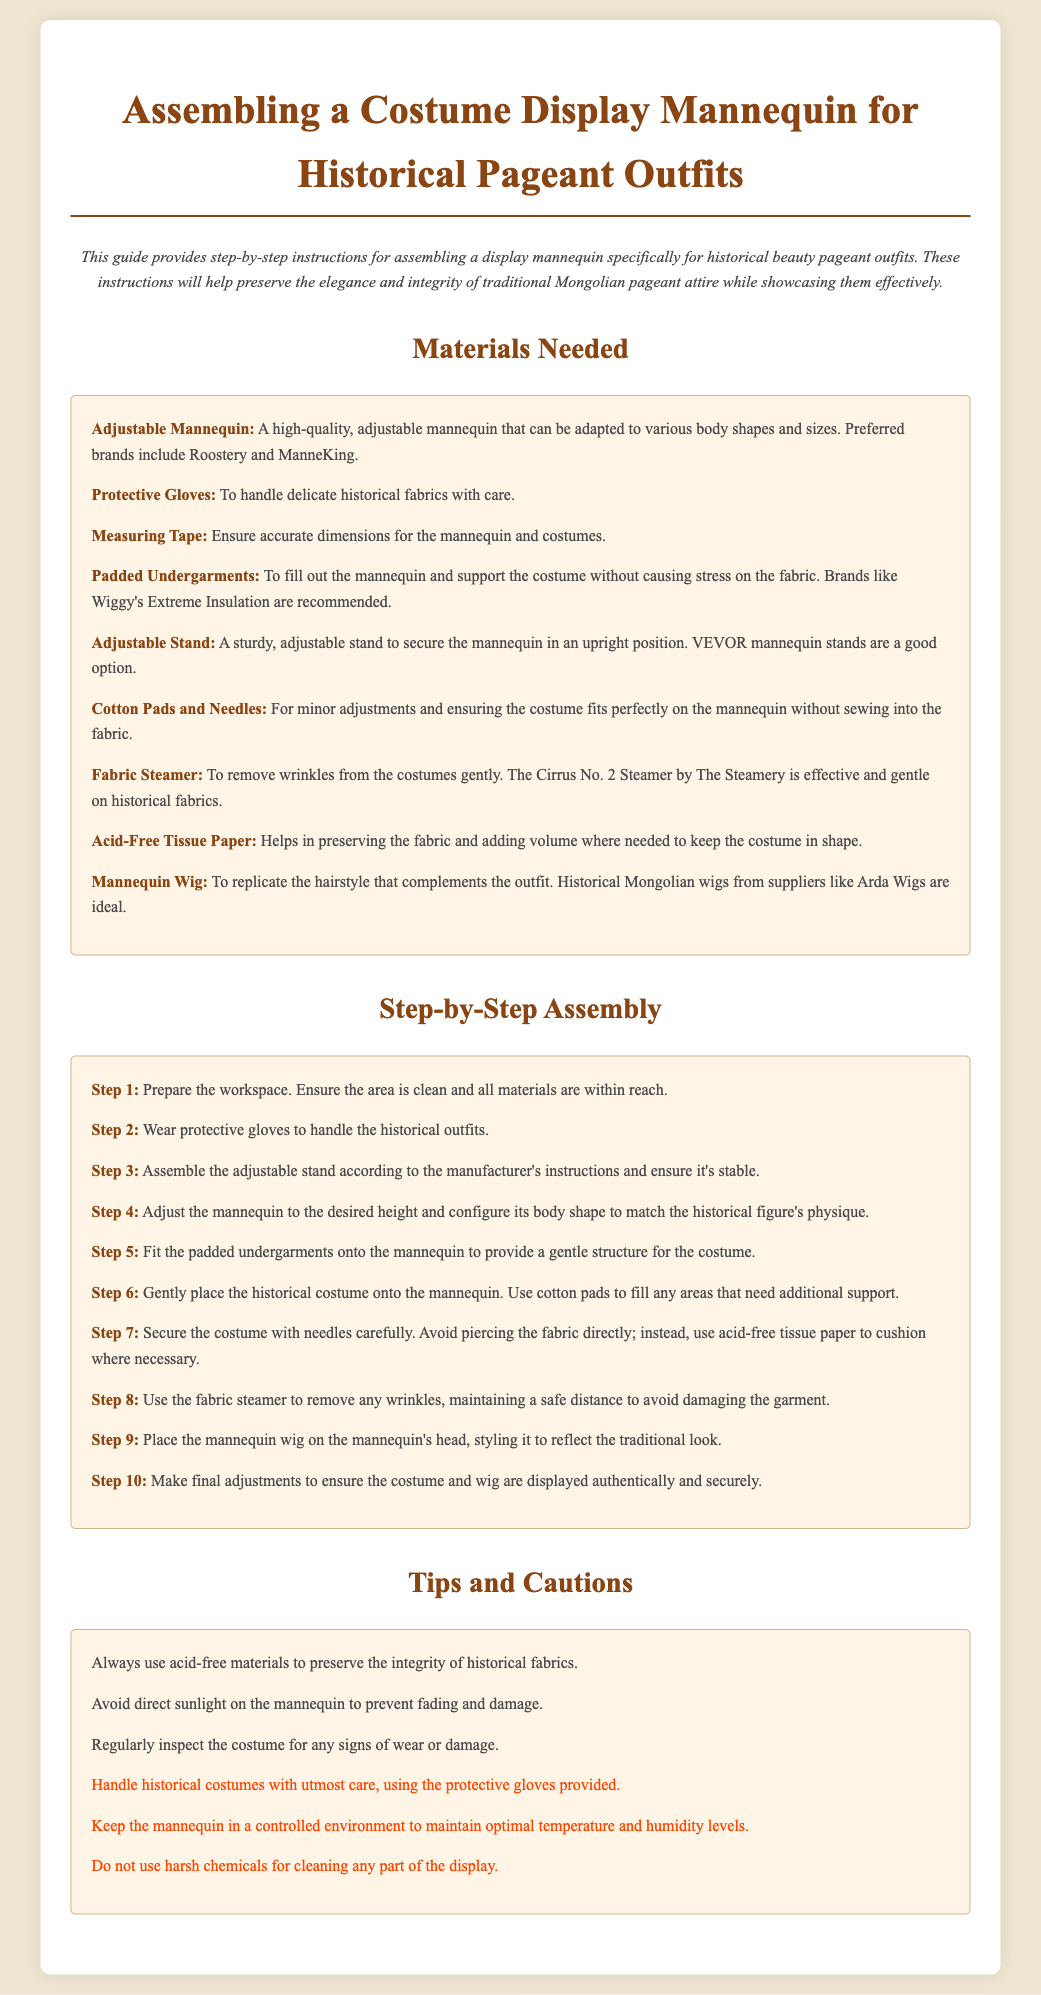What is the title of the document? The title of the document is specified at the beginning of the HTML file, indicating its purpose.
Answer: Assembling a Costume Display Mannequin for Historical Pageant Outfits What material is recommended for handling delicate historical fabrics? The document lists specific materials needed for assembly, one being specifically for protective handling.
Answer: Protective Gloves How many steps are there in the assembly process? The document lists a series of steps for assembly, with a clear enumeration of them.
Answer: 10 Which brand of fabric steamer is mentioned? The document names a specific steamer brand that is gentle on historical fabrics, indicating preference for its use.
Answer: The Steamery What should be avoided when securing the costume? The document provides guidance on care with respect to securing the costume as a cautionary measure.
Answer: Piercing the fabric directly What is to be filled in the mannequin to support the costume? The document specifies a particular item that provides structure to the mannequin for costume support.
Answer: Padded Undergarments What type of paper is recommended for preserving fabric? The document includes a transitional material used to help maintain the integrity and shape of the costumes.
Answer: Acid-Free Tissue Paper What is advised against for cleaning the display? The document offers cautionary advice regarding cleaning methods for the mannequin and costume.
Answer: Harsh chemicals What should be used to remove wrinkles from the costume? The document mentions a specific tool that is used to ensure the costumes look presentable and wrinkle-free.
Answer: Fabric Steamer 